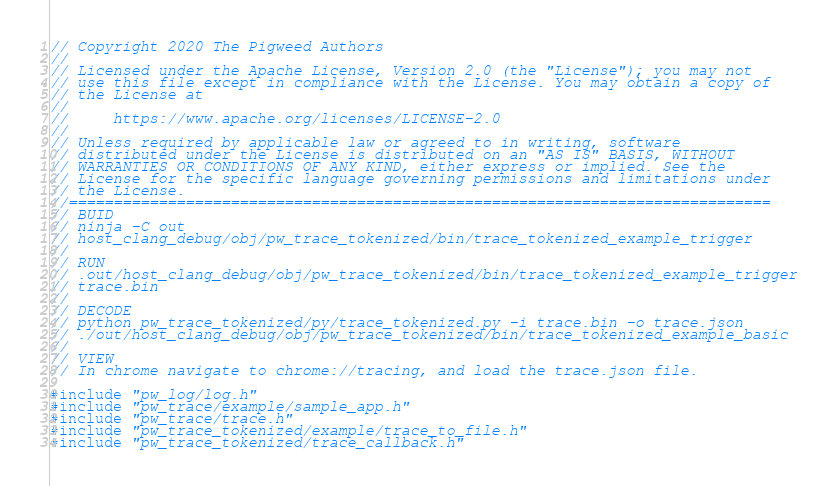<code> <loc_0><loc_0><loc_500><loc_500><_C++_>// Copyright 2020 The Pigweed Authors
//
// Licensed under the Apache License, Version 2.0 (the "License"); you may not
// use this file except in compliance with the License. You may obtain a copy of
// the License at
//
//     https://www.apache.org/licenses/LICENSE-2.0
//
// Unless required by applicable law or agreed to in writing, software
// distributed under the License is distributed on an "AS IS" BASIS, WITHOUT
// WARRANTIES OR CONDITIONS OF ANY KIND, either express or implied. See the
// License for the specific language governing permissions and limitations under
// the License.
//==============================================================================
// BUID
// ninja -C out
// host_clang_debug/obj/pw_trace_tokenized/bin/trace_tokenized_example_trigger
//
// RUN
// .out/host_clang_debug/obj/pw_trace_tokenized/bin/trace_tokenized_example_trigger
// trace.bin
//
// DECODE
// python pw_trace_tokenized/py/trace_tokenized.py -i trace.bin -o trace.json
// ./out/host_clang_debug/obj/pw_trace_tokenized/bin/trace_tokenized_example_basic
//
// VIEW
// In chrome navigate to chrome://tracing, and load the trace.json file.

#include "pw_log/log.h"
#include "pw_trace/example/sample_app.h"
#include "pw_trace/trace.h"
#include "pw_trace_tokenized/example/trace_to_file.h"
#include "pw_trace_tokenized/trace_callback.h"</code> 